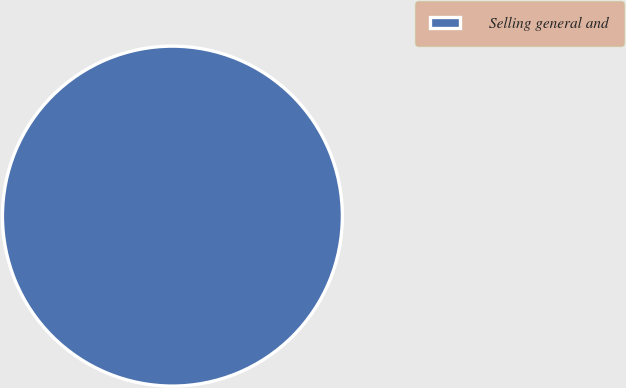Convert chart. <chart><loc_0><loc_0><loc_500><loc_500><pie_chart><fcel>Selling general and<nl><fcel>100.0%<nl></chart> 